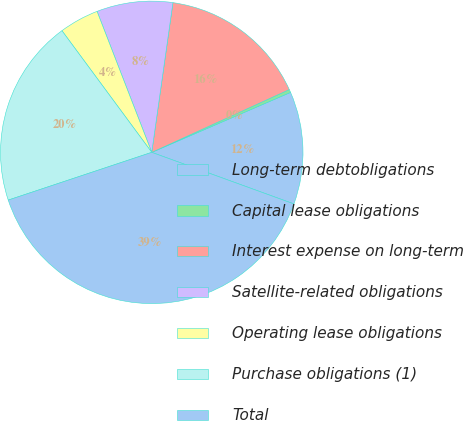Convert chart. <chart><loc_0><loc_0><loc_500><loc_500><pie_chart><fcel>Long-term debtobligations<fcel>Capital lease obligations<fcel>Interest expense on long-term<fcel>Satellite-related obligations<fcel>Operating lease obligations<fcel>Purchase obligations (1)<fcel>Total<nl><fcel>12.03%<fcel>0.33%<fcel>15.94%<fcel>8.13%<fcel>4.23%<fcel>19.99%<fcel>39.35%<nl></chart> 